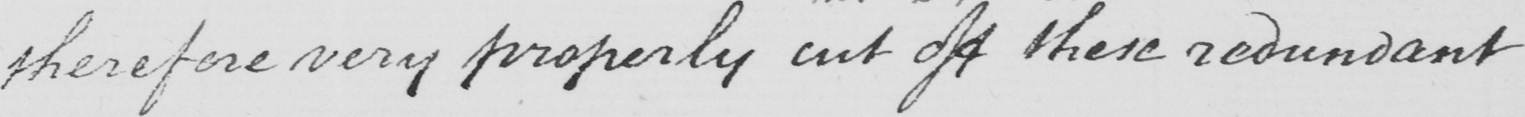What does this handwritten line say? therefore very properly cut off these redundant 